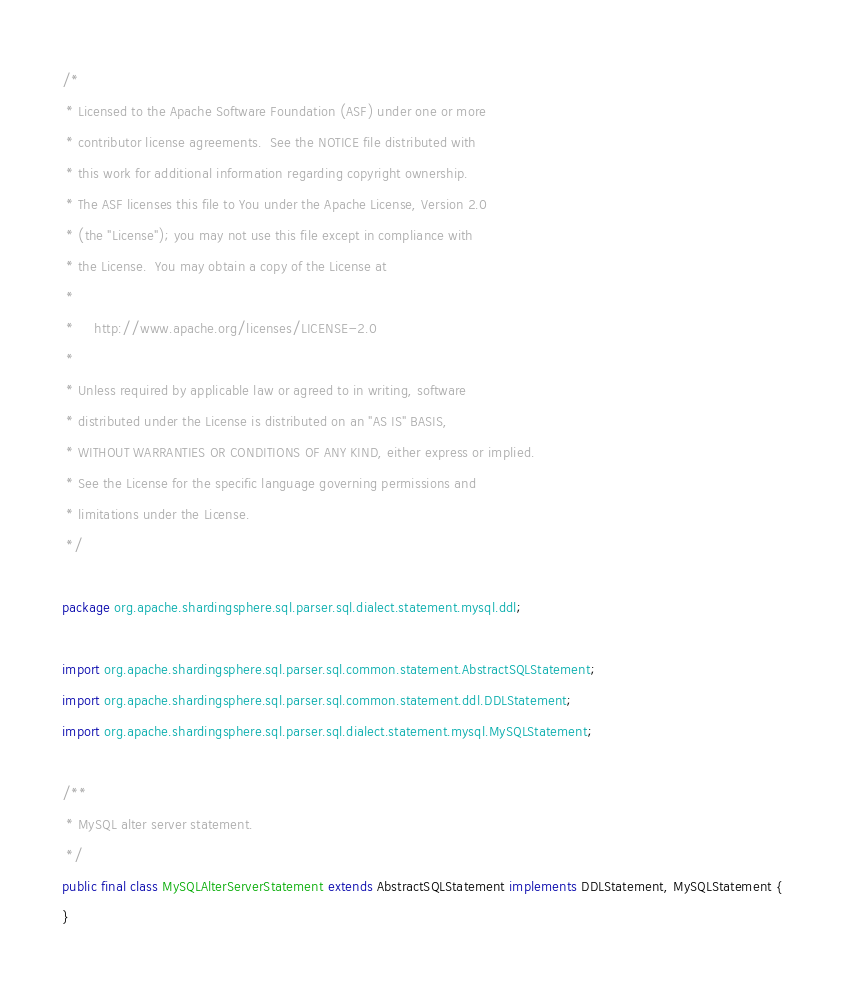<code> <loc_0><loc_0><loc_500><loc_500><_Java_>/*
 * Licensed to the Apache Software Foundation (ASF) under one or more
 * contributor license agreements.  See the NOTICE file distributed with
 * this work for additional information regarding copyright ownership.
 * The ASF licenses this file to You under the Apache License, Version 2.0
 * (the "License"); you may not use this file except in compliance with
 * the License.  You may obtain a copy of the License at
 *
 *     http://www.apache.org/licenses/LICENSE-2.0
 *
 * Unless required by applicable law or agreed to in writing, software
 * distributed under the License is distributed on an "AS IS" BASIS,
 * WITHOUT WARRANTIES OR CONDITIONS OF ANY KIND, either express or implied.
 * See the License for the specific language governing permissions and
 * limitations under the License.
 */

package org.apache.shardingsphere.sql.parser.sql.dialect.statement.mysql.ddl;

import org.apache.shardingsphere.sql.parser.sql.common.statement.AbstractSQLStatement;
import org.apache.shardingsphere.sql.parser.sql.common.statement.ddl.DDLStatement;
import org.apache.shardingsphere.sql.parser.sql.dialect.statement.mysql.MySQLStatement;

/**
 * MySQL alter server statement.
 */
public final class MySQLAlterServerStatement extends AbstractSQLStatement implements DDLStatement, MySQLStatement {
}
</code> 